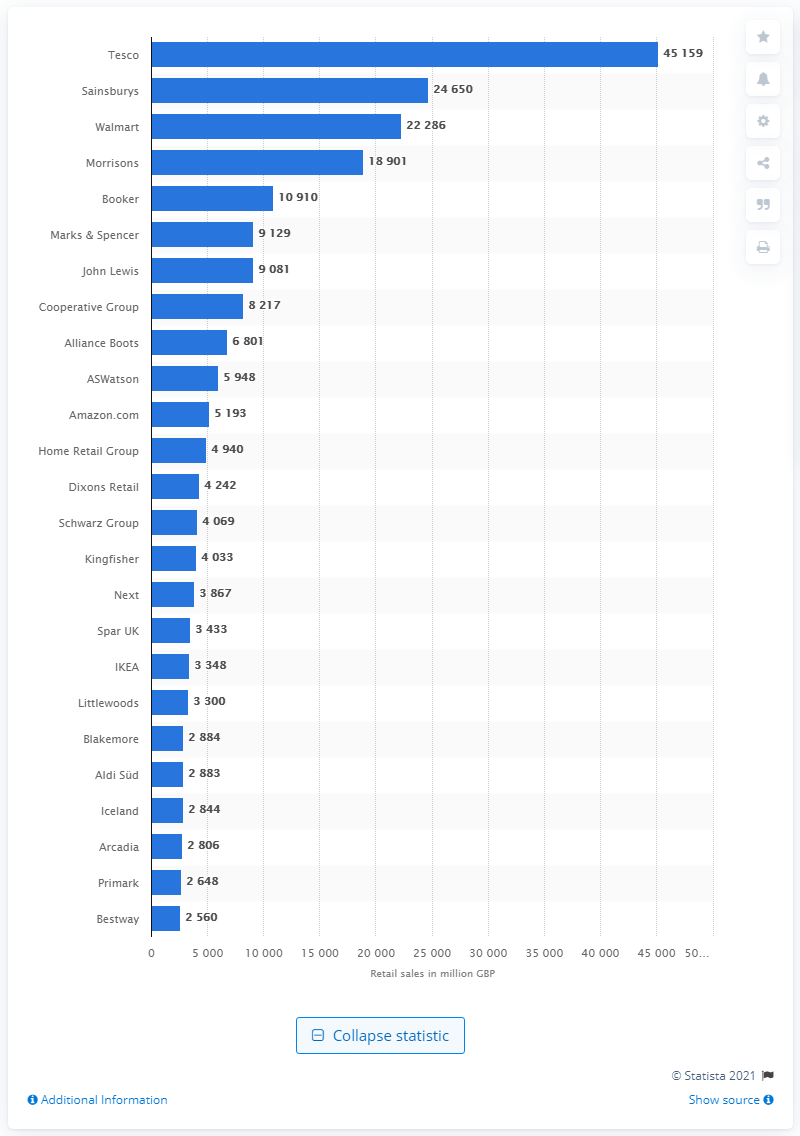Indicate a few pertinent items in this graphic. In July 2013, Tesco was the highest ranked retail store in the United Kingdom. 